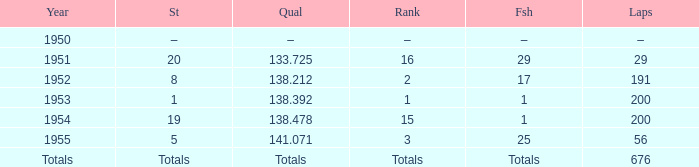How many laps does the one ranked 16 have? 29.0. 